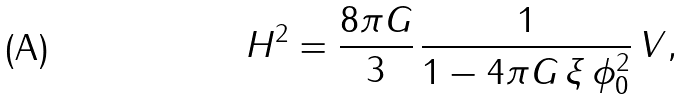<formula> <loc_0><loc_0><loc_500><loc_500>H ^ { 2 } = \frac { 8 \pi G } { 3 } \, \frac { 1 } { 1 - 4 \pi G \, \xi \, \phi _ { 0 } ^ { 2 } } \, V ,</formula> 